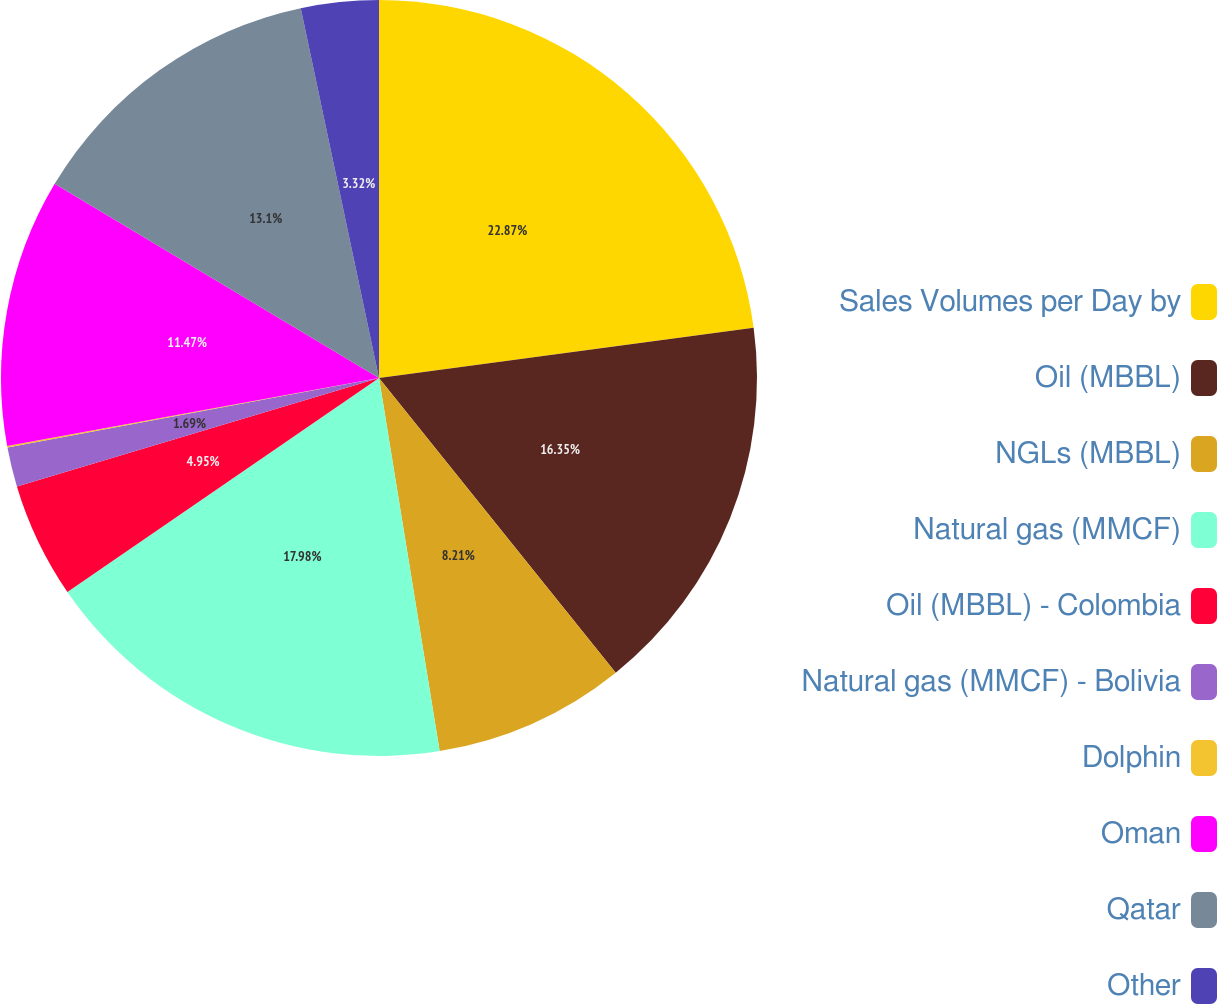Convert chart to OTSL. <chart><loc_0><loc_0><loc_500><loc_500><pie_chart><fcel>Sales Volumes per Day by<fcel>Oil (MBBL)<fcel>NGLs (MBBL)<fcel>Natural gas (MMCF)<fcel>Oil (MBBL) - Colombia<fcel>Natural gas (MMCF) - Bolivia<fcel>Dolphin<fcel>Oman<fcel>Qatar<fcel>Other<nl><fcel>22.88%<fcel>16.36%<fcel>8.21%<fcel>17.99%<fcel>4.95%<fcel>1.69%<fcel>0.06%<fcel>11.47%<fcel>13.1%<fcel>3.32%<nl></chart> 